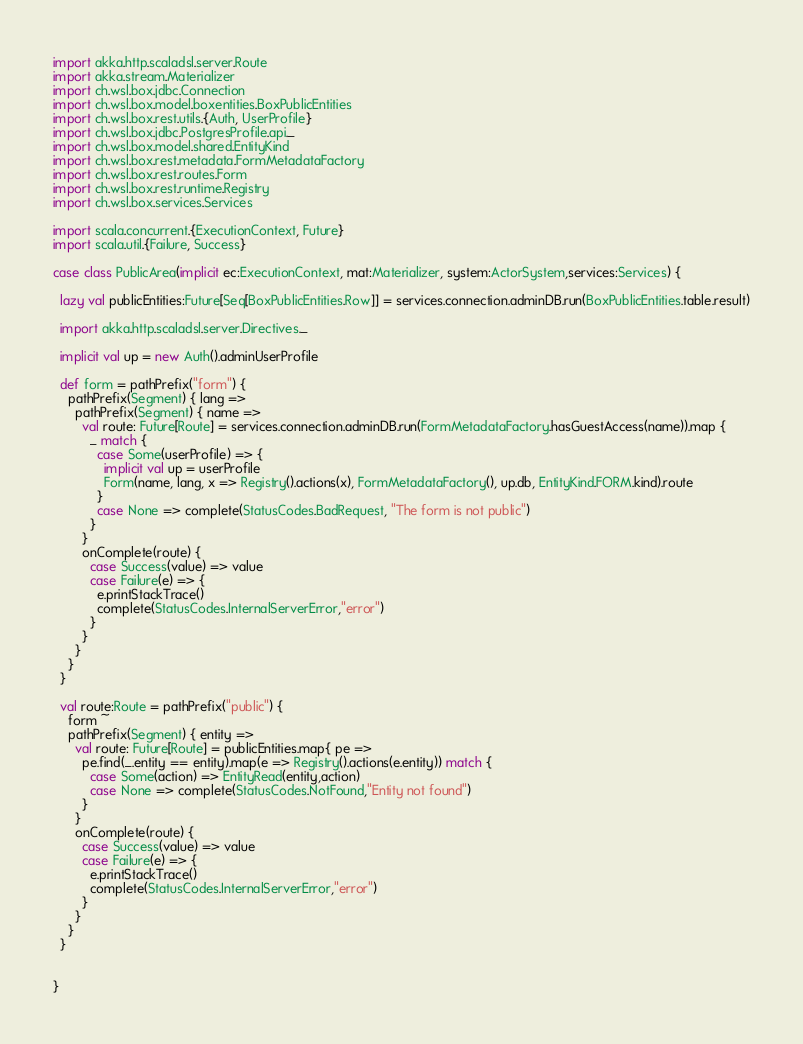<code> <loc_0><loc_0><loc_500><loc_500><_Scala_>import akka.http.scaladsl.server.Route
import akka.stream.Materializer
import ch.wsl.box.jdbc.Connection
import ch.wsl.box.model.boxentities.BoxPublicEntities
import ch.wsl.box.rest.utils.{Auth, UserProfile}
import ch.wsl.box.jdbc.PostgresProfile.api._
import ch.wsl.box.model.shared.EntityKind
import ch.wsl.box.rest.metadata.FormMetadataFactory
import ch.wsl.box.rest.routes.Form
import ch.wsl.box.rest.runtime.Registry
import ch.wsl.box.services.Services

import scala.concurrent.{ExecutionContext, Future}
import scala.util.{Failure, Success}

case class PublicArea(implicit ec:ExecutionContext, mat:Materializer, system:ActorSystem,services:Services) {

  lazy val publicEntities:Future[Seq[BoxPublicEntities.Row]] = services.connection.adminDB.run(BoxPublicEntities.table.result)

  import akka.http.scaladsl.server.Directives._

  implicit val up = new Auth().adminUserProfile

  def form = pathPrefix("form") {
    pathPrefix(Segment) { lang =>
      pathPrefix(Segment) { name =>
        val route: Future[Route] = services.connection.adminDB.run(FormMetadataFactory.hasGuestAccess(name)).map {
          _ match {
            case Some(userProfile) => {
              implicit val up = userProfile
              Form(name, lang, x => Registry().actions(x), FormMetadataFactory(), up.db, EntityKind.FORM.kind).route
            }
            case None => complete(StatusCodes.BadRequest, "The form is not public")
          }
        }
        onComplete(route) {
          case Success(value) => value
          case Failure(e) => {
            e.printStackTrace()
            complete(StatusCodes.InternalServerError,"error")
          }
        }
      }
    }
  }

  val route:Route = pathPrefix("public") {
    form ~
    pathPrefix(Segment) { entity =>
      val route: Future[Route] = publicEntities.map{ pe =>
        pe.find(_.entity == entity).map(e => Registry().actions(e.entity)) match {
          case Some(action) => EntityRead(entity,action)
          case None => complete(StatusCodes.NotFound,"Entity not found")
        }
      }
      onComplete(route) {
        case Success(value) => value
        case Failure(e) => {
          e.printStackTrace()
          complete(StatusCodes.InternalServerError,"error")
        }
      }
    }
  }


}
</code> 